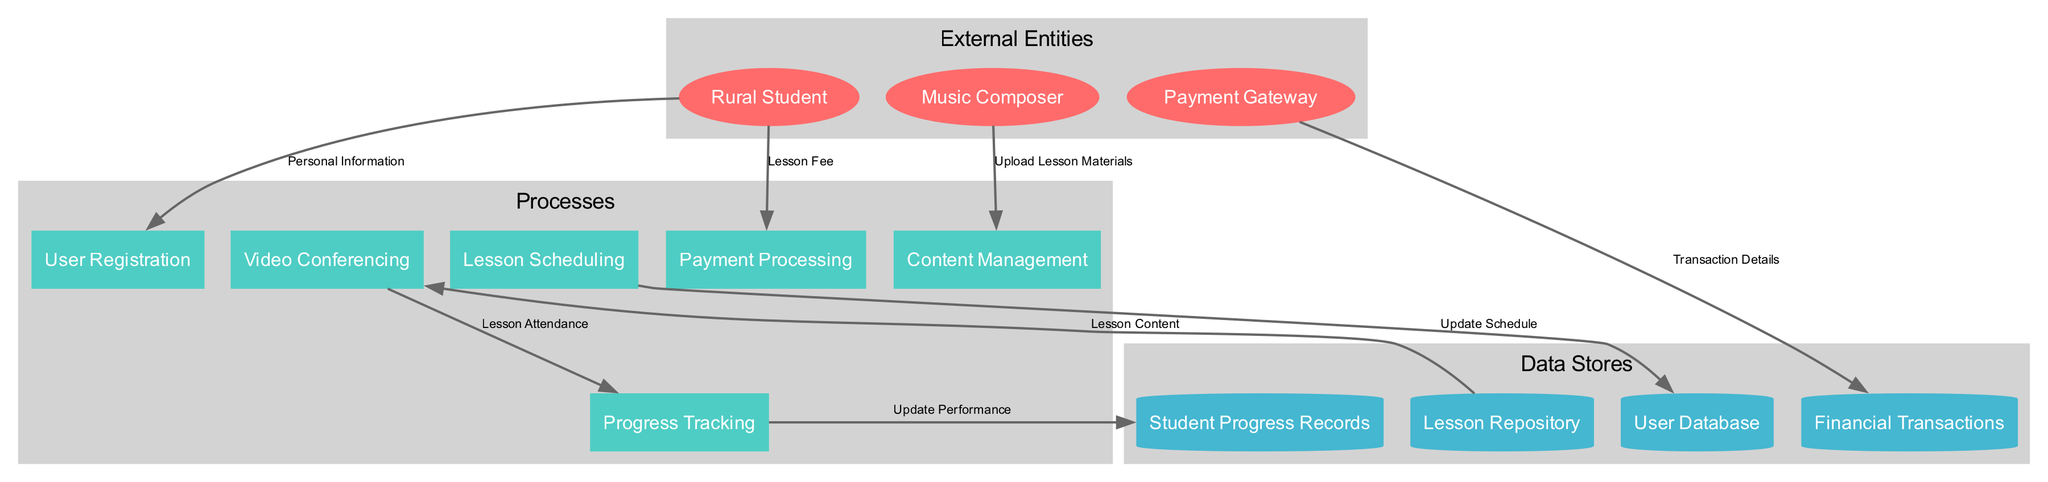What are the external entities in the diagram? The external entities listed in the diagram include Rural Student, Music Composer, and Payment Gateway.
Answer: Rural Student, Music Composer, Payment Gateway How many processes are involved in the platform? The diagram lists six processes: User Registration, Lesson Scheduling, Video Conferencing, Content Management, Progress Tracking, and Payment Processing. Therefore, the total number of processes is six.
Answer: 6 Which process does the Rural Student provide personal information to? The Rural Student flows personal information to the User Registration process, as indicated in the data flow description.
Answer: User Registration What data store is updated by Lesson Scheduling? The Lesson Scheduling process updates the User Database according to the data flow relationships depicted in the diagram.
Answer: User Database What type of data does the Payment Gateway send to Financial Transactions? The Payment Gateway sends Transaction Details to the Financial Transactions data store, as specified in the data flow descriptions from the diagram.
Answer: Transaction Details Which process receives the Lesson Content? The Video Conferencing process receives Lesson Content from the Lesson Repository, as laid out in the flows of the diagram.
Answer: Video Conferencing What does Progress Tracking update? The Progress Tracking process updates the Student Progress Records by following the specified data flow in the diagram.
Answer: Student Progress Records What label is given to the flow from Music Composer to Content Management? The flow from Music Composer to Content Management is labeled "Upload Lesson Materials," according to the details provided in the data flows section of the diagram.
Answer: Upload Lesson Materials How many data stores are shown in the diagram? The diagram depicts four data stores: User Database, Lesson Repository, Student Progress Records, and Financial Transactions, totaling four data stores.
Answer: 4 